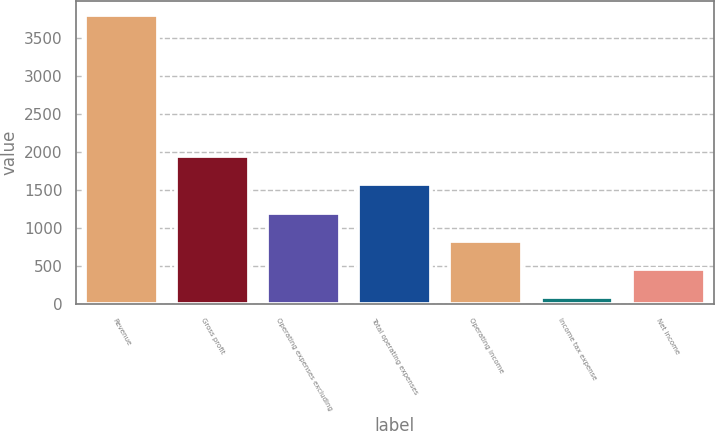Convert chart. <chart><loc_0><loc_0><loc_500><loc_500><bar_chart><fcel>Revenue<fcel>Gross profit<fcel>Operating expenses excluding<fcel>Total operating expenses<fcel>Operating income<fcel>Income tax expense<fcel>Net income<nl><fcel>3791<fcel>1941<fcel>1201<fcel>1571<fcel>831<fcel>91<fcel>461<nl></chart> 